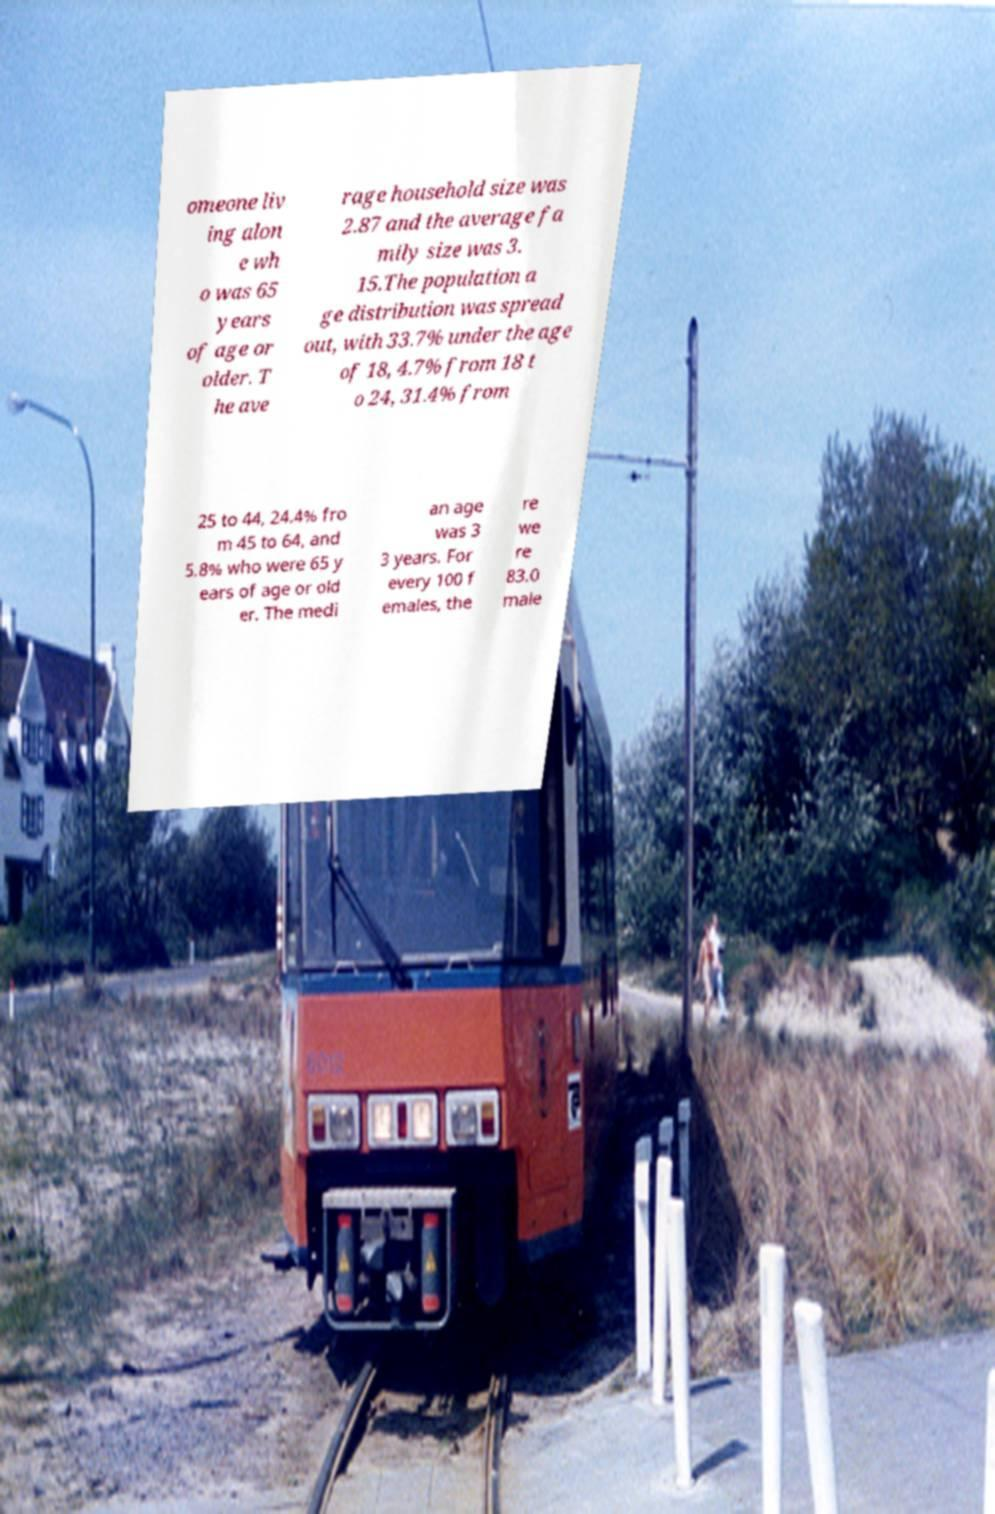For documentation purposes, I need the text within this image transcribed. Could you provide that? omeone liv ing alon e wh o was 65 years of age or older. T he ave rage household size was 2.87 and the average fa mily size was 3. 15.The population a ge distribution was spread out, with 33.7% under the age of 18, 4.7% from 18 t o 24, 31.4% from 25 to 44, 24.4% fro m 45 to 64, and 5.8% who were 65 y ears of age or old er. The medi an age was 3 3 years. For every 100 f emales, the re we re 83.0 male 